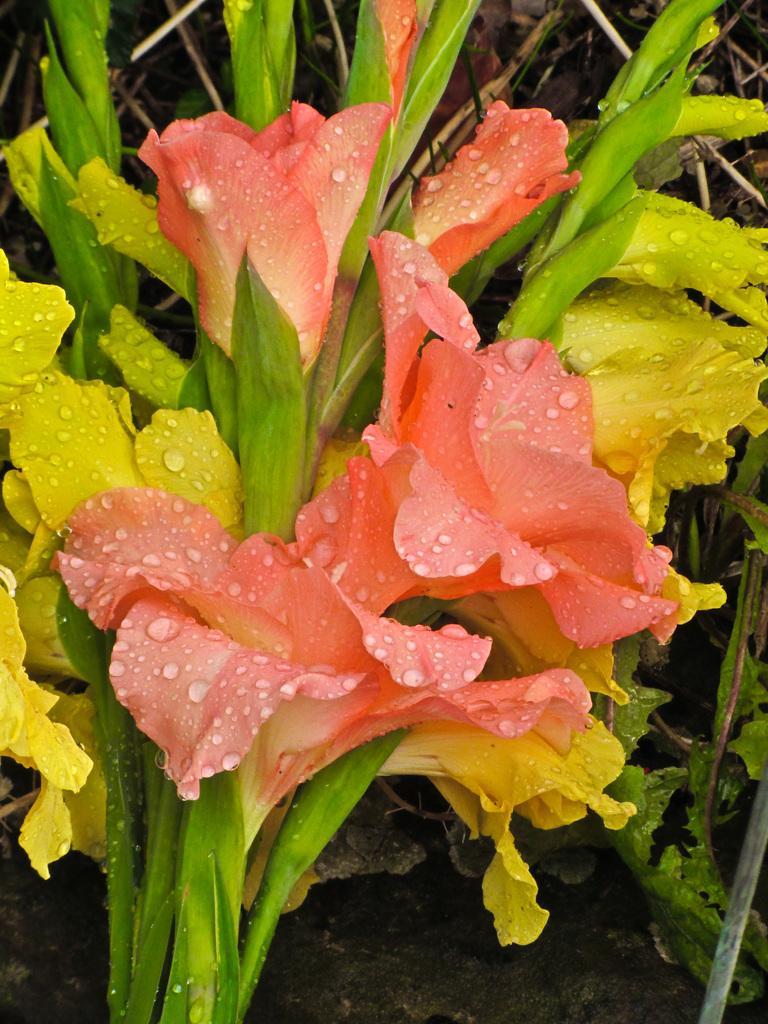How would you summarize this image in a sentence or two? In the picture I can see orange and yellow color flowers on which I can see water droplets. 